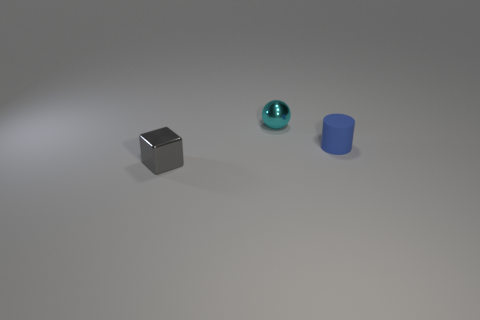Add 1 tiny spheres. How many objects exist? 4 Subtract all blocks. How many objects are left? 2 Subtract 0 yellow cylinders. How many objects are left? 3 Subtract all shiny objects. Subtract all small blue cylinders. How many objects are left? 0 Add 2 tiny metallic cubes. How many tiny metallic cubes are left? 3 Add 2 big cyan spheres. How many big cyan spheres exist? 2 